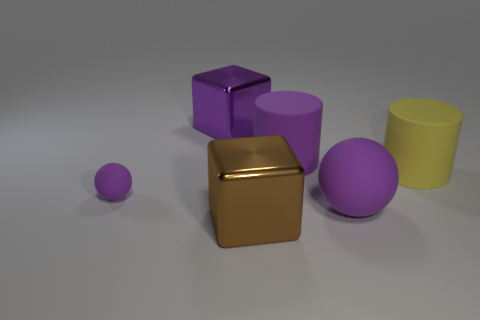The small object that is the same color as the big matte sphere is what shape?
Your response must be concise. Sphere. There is a brown metal object; what number of big things are to the left of it?
Keep it short and to the point. 1. What color is the large ball?
Ensure brevity in your answer.  Purple. What number of tiny things are either blocks or cyan matte balls?
Provide a succinct answer. 0. Is the color of the metallic block that is in front of the small thing the same as the matte ball in front of the tiny rubber thing?
Make the answer very short. No. What number of other objects are the same color as the large sphere?
Ensure brevity in your answer.  3. What shape is the big purple object left of the large purple cylinder?
Your response must be concise. Cube. Are there fewer shiny objects than big green matte spheres?
Your answer should be very brief. No. Are the purple sphere to the right of the tiny matte thing and the brown cube made of the same material?
Your response must be concise. No. Are there any other things that have the same size as the yellow rubber cylinder?
Ensure brevity in your answer.  Yes. 